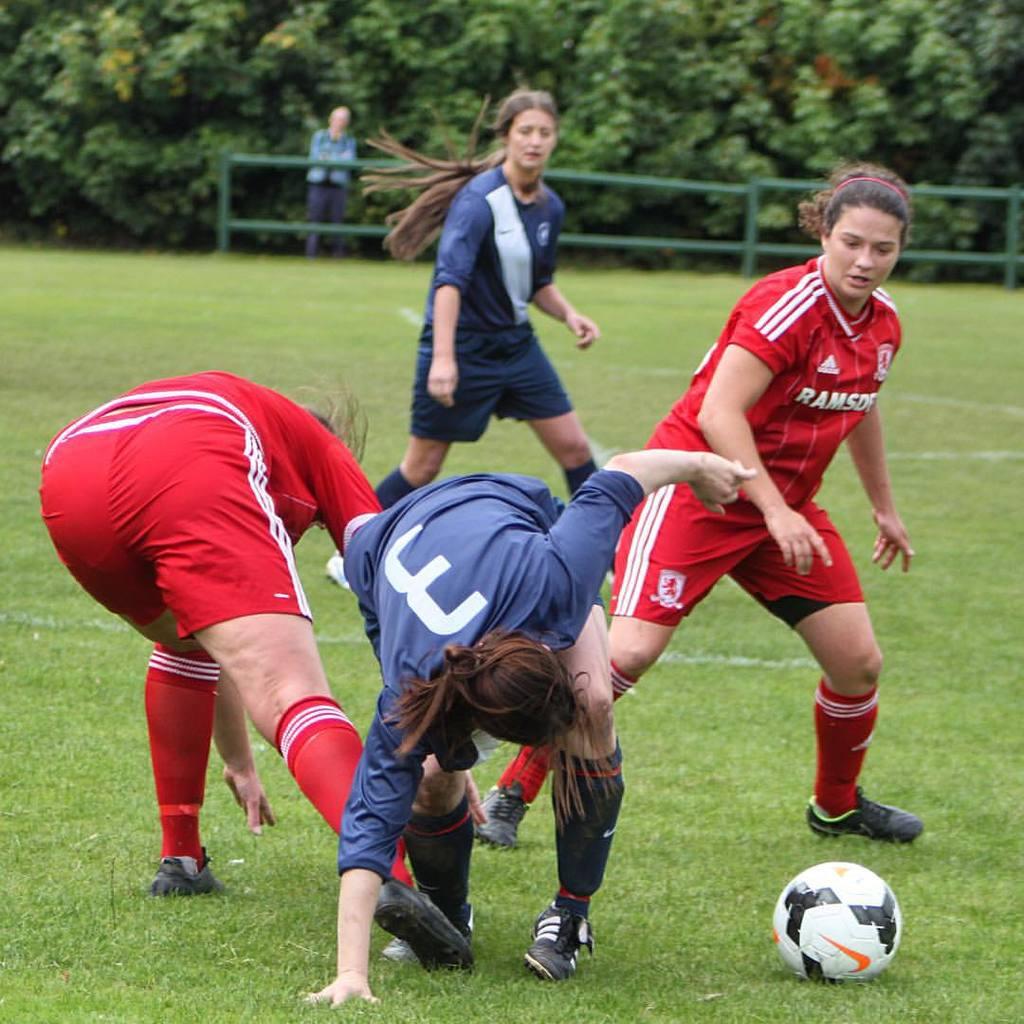What is the player's number who is wearing a blue shirt and bent over with one hand on the ground?
Ensure brevity in your answer.  3. What is the name of the red team?
Ensure brevity in your answer.  Ramsof. 